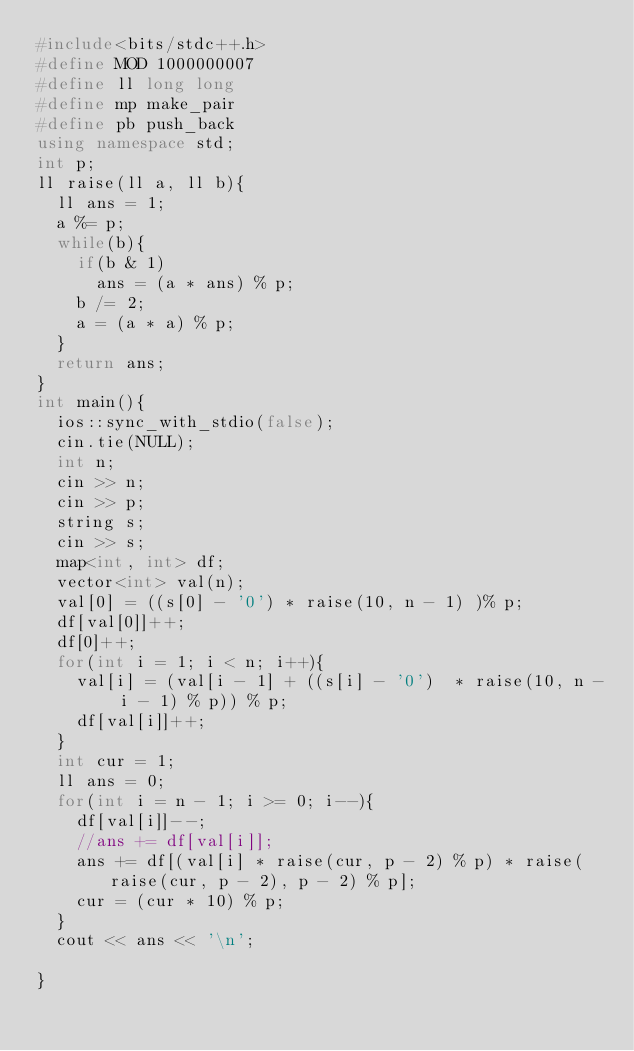Convert code to text. <code><loc_0><loc_0><loc_500><loc_500><_C++_>#include<bits/stdc++.h>
#define MOD 1000000007
#define ll long long
#define mp make_pair
#define pb push_back 
using namespace std;
int p;
ll raise(ll a, ll b){
	ll ans = 1;
	a %= p;
	while(b){
		if(b & 1)
			ans = (a * ans) % p;
		b /= 2;
		a = (a * a) % p;
	}
	return ans;
}
int main(){
	ios::sync_with_stdio(false);
	cin.tie(NULL);
	int n;
	cin >> n;
	cin >> p;
	string s;
	cin >> s;
	map<int, int> df;
	vector<int> val(n);
	val[0] = ((s[0] - '0') * raise(10, n - 1) )% p;
	df[val[0]]++;
	df[0]++;
	for(int i = 1; i < n; i++){
		val[i] = (val[i - 1] + ((s[i] - '0')  * raise(10, n - i - 1) % p)) % p;
		df[val[i]]++;
	}
	int cur = 1;
	ll ans = 0;
	for(int i = n - 1; i >= 0; i--){
		df[val[i]]--;
		//ans += df[val[i]];
		ans += df[(val[i] * raise(cur, p - 2) % p) * raise(raise(cur, p - 2), p - 2) % p]; 
		cur = (cur * 10) % p;
	}
	cout << ans << '\n';

}</code> 